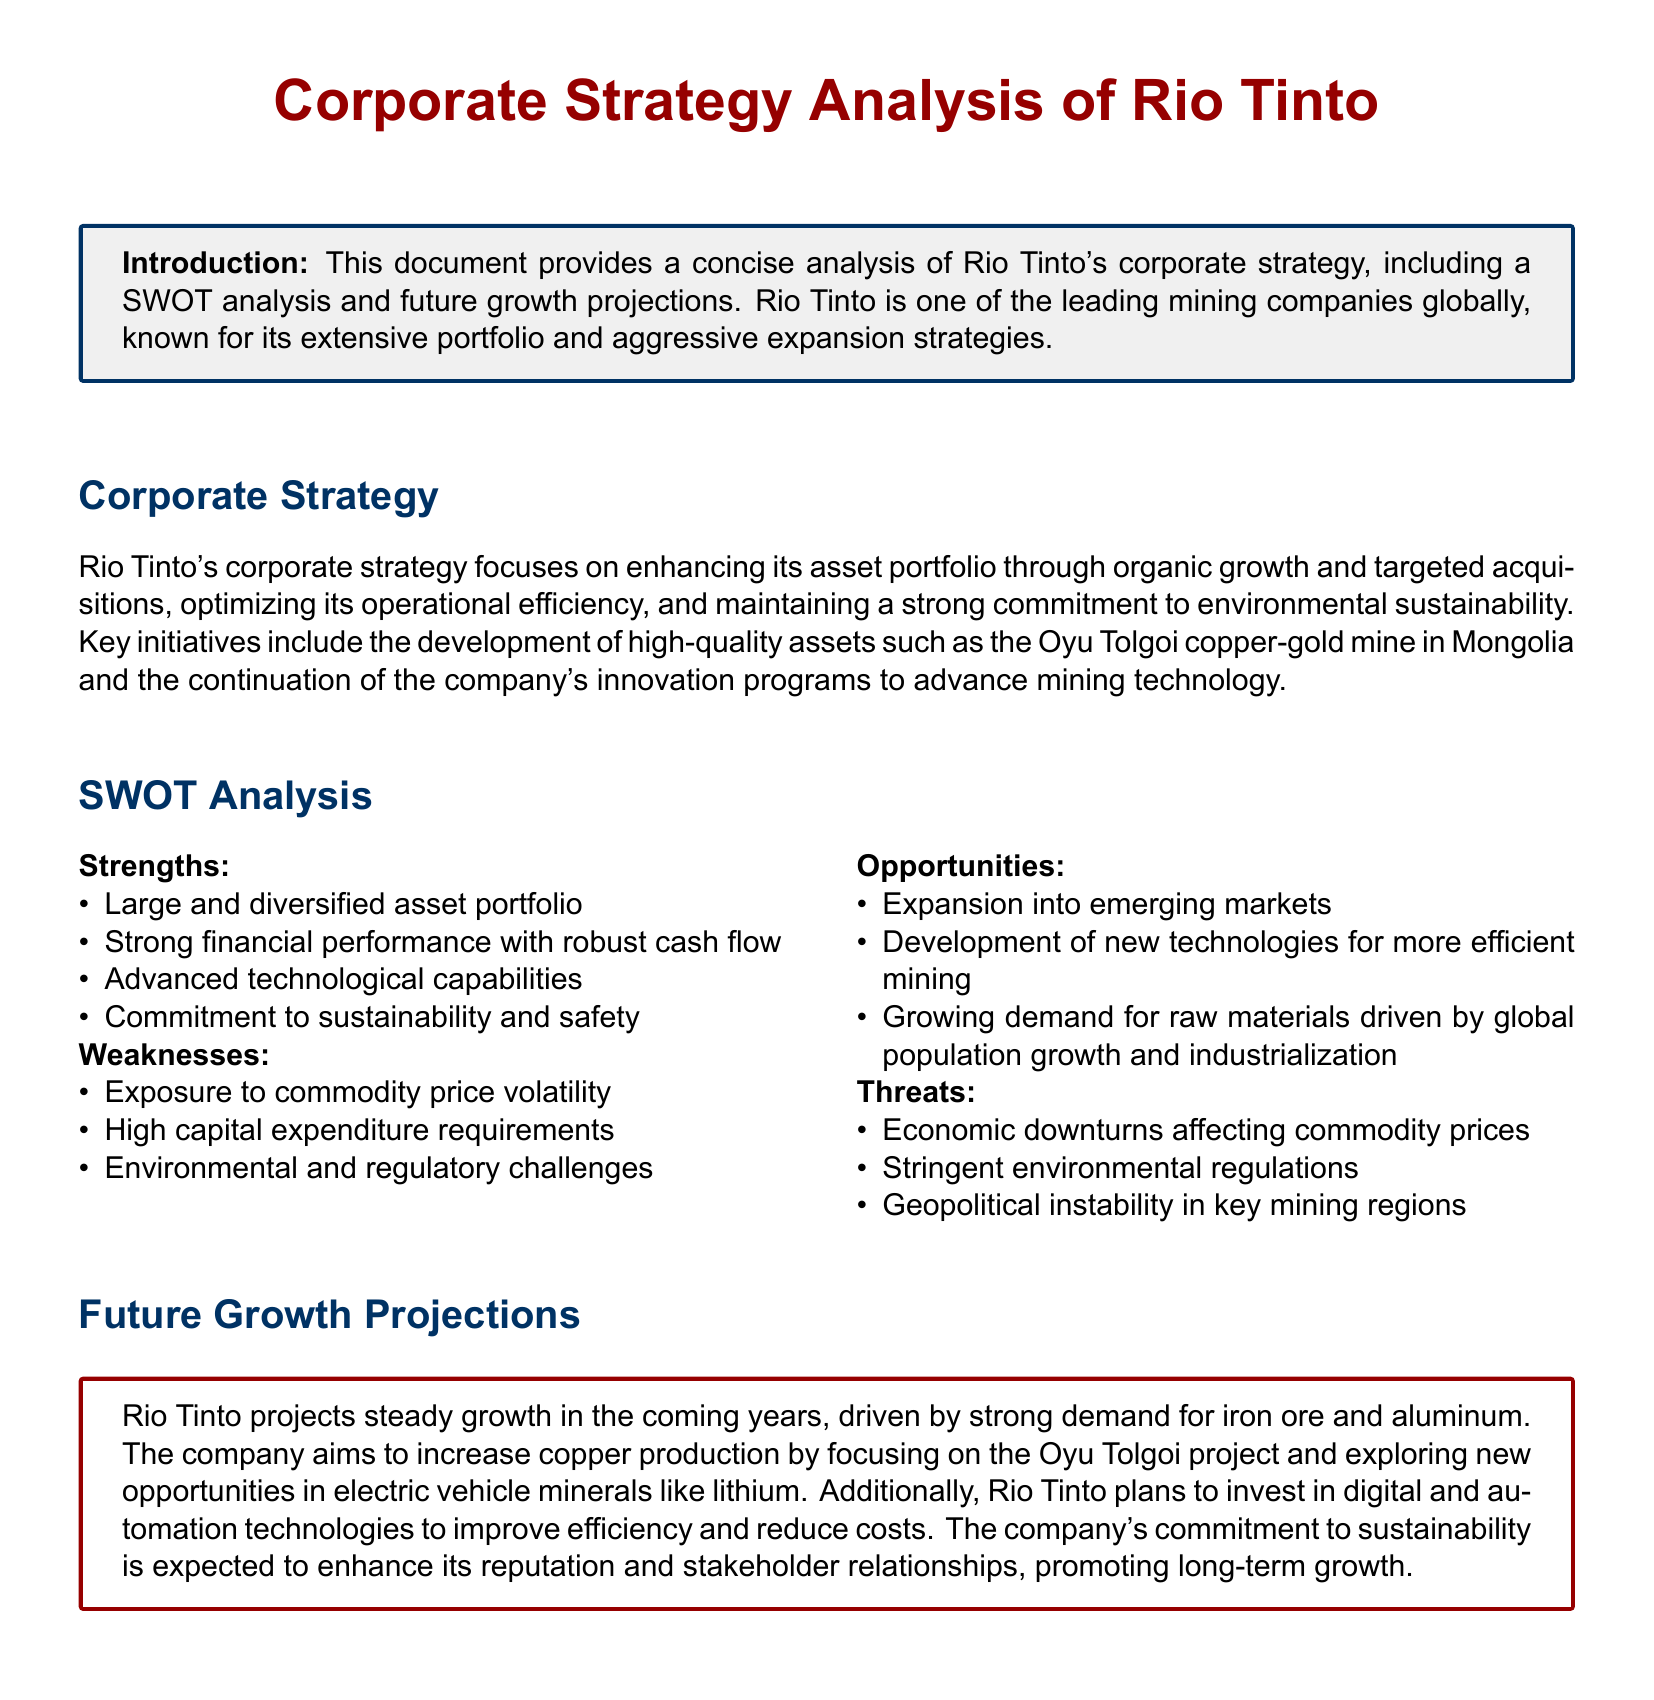what is the title of the document? The title is prominently displayed at the top of the document.
Answer: Corporate Strategy Analysis of Rio Tinto what are the key initiatives mentioned in Rio Tinto's corporate strategy? The key initiatives are outlined in a concise manner in the corporate strategy section of the document.
Answer: Development of high-quality assets, innovation programs what is a major weakness listed in the SWOT analysis? The document lists specific weaknesses in the SWOT analysis section.
Answer: Exposure to commodity price volatility what opportunities does Rio Tinto have according to the document? The opportunities are detailed in the SWOT analysis section, which highlights potential growth areas for the company.
Answer: Expansion into emerging markets what is one threat identified in the SWOT analysis? The threats section of the SWOT analysis lists various external challenges Rio Tinto faces.
Answer: Geopolitical instability in key mining regions what future project is Rio Tinto focusing on to increase copper production? The document specifies a particular project related to copper production growth in the future projections section.
Answer: Oyu Tolgoi project how is Rio Tinto planning to improve efficiency? The future growth projections section mentions specific strategies for enhancing operational efficiency.
Answer: Investing in digital and automation technologies what color is used for the section titles? The document specifies a color scheme for its various elements, including the section titles.
Answer: myblue what does Rio Tinto project for its growth in the coming years? The future growth projections section contains a summary of the company's expectations for growth.
Answer: Steady growth 